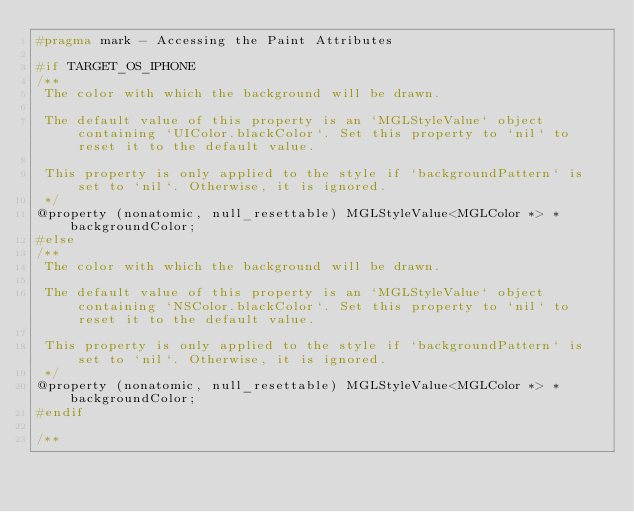Convert code to text. <code><loc_0><loc_0><loc_500><loc_500><_C_>#pragma mark - Accessing the Paint Attributes

#if TARGET_OS_IPHONE
/**
 The color with which the background will be drawn.
 
 The default value of this property is an `MGLStyleValue` object containing `UIColor.blackColor`. Set this property to `nil` to reset it to the default value.

 This property is only applied to the style if `backgroundPattern` is set to `nil`. Otherwise, it is ignored.
 */
@property (nonatomic, null_resettable) MGLStyleValue<MGLColor *> *backgroundColor;
#else
/**
 The color with which the background will be drawn.
 
 The default value of this property is an `MGLStyleValue` object containing `NSColor.blackColor`. Set this property to `nil` to reset it to the default value.

 This property is only applied to the style if `backgroundPattern` is set to `nil`. Otherwise, it is ignored.
 */
@property (nonatomic, null_resettable) MGLStyleValue<MGLColor *> *backgroundColor;
#endif

/**</code> 